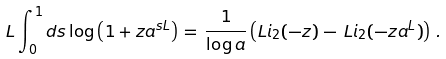Convert formula to latex. <formula><loc_0><loc_0><loc_500><loc_500>L \int _ { 0 } ^ { 1 } d s \log \left ( 1 + z a ^ { s L } \right ) \, = \, \frac { 1 } { \log a } \left ( L i _ { 2 } ( - z ) \, - \, L i _ { 2 } ( - z a ^ { L } ) \right ) \, .</formula> 